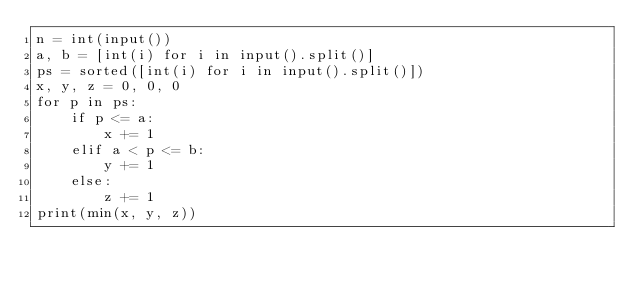<code> <loc_0><loc_0><loc_500><loc_500><_Python_>n = int(input())
a, b = [int(i) for i in input().split()]
ps = sorted([int(i) for i in input().split()])
x, y, z = 0, 0, 0
for p in ps:
    if p <= a:
        x += 1
    elif a < p <= b:
        y += 1
    else:
        z += 1
print(min(x, y, z))</code> 